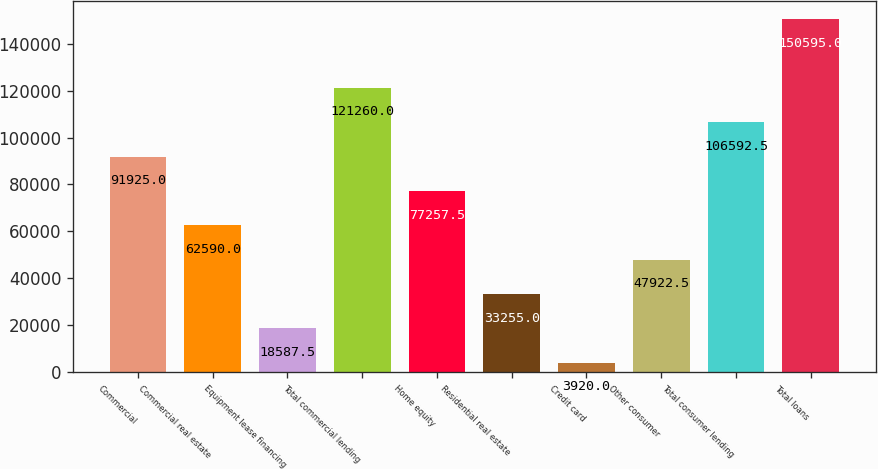Convert chart to OTSL. <chart><loc_0><loc_0><loc_500><loc_500><bar_chart><fcel>Commercial<fcel>Commercial real estate<fcel>Equipment lease financing<fcel>Total commercial lending<fcel>Home equity<fcel>Residential real estate<fcel>Credit card<fcel>Other consumer<fcel>Total consumer lending<fcel>Total loans<nl><fcel>91925<fcel>62590<fcel>18587.5<fcel>121260<fcel>77257.5<fcel>33255<fcel>3920<fcel>47922.5<fcel>106592<fcel>150595<nl></chart> 